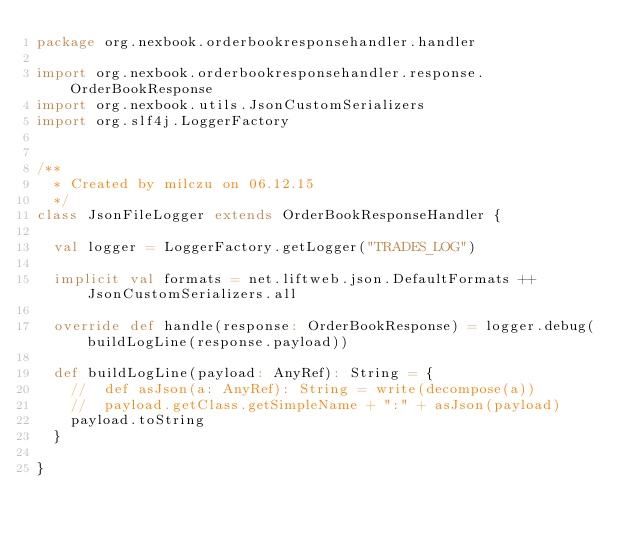Convert code to text. <code><loc_0><loc_0><loc_500><loc_500><_Scala_>package org.nexbook.orderbookresponsehandler.handler

import org.nexbook.orderbookresponsehandler.response.OrderBookResponse
import org.nexbook.utils.JsonCustomSerializers
import org.slf4j.LoggerFactory


/**
  * Created by milczu on 06.12.15
  */
class JsonFileLogger extends OrderBookResponseHandler {

  val logger = LoggerFactory.getLogger("TRADES_LOG")

  implicit val formats = net.liftweb.json.DefaultFormats ++ JsonCustomSerializers.all

  override def handle(response: OrderBookResponse) = logger.debug(buildLogLine(response.payload))

  def buildLogLine(payload: AnyRef): String = {
	//	def asJson(a: AnyRef): String = write(decompose(a))
	//	payload.getClass.getSimpleName + ":" + asJson(payload)
	payload.toString
  }

}
</code> 